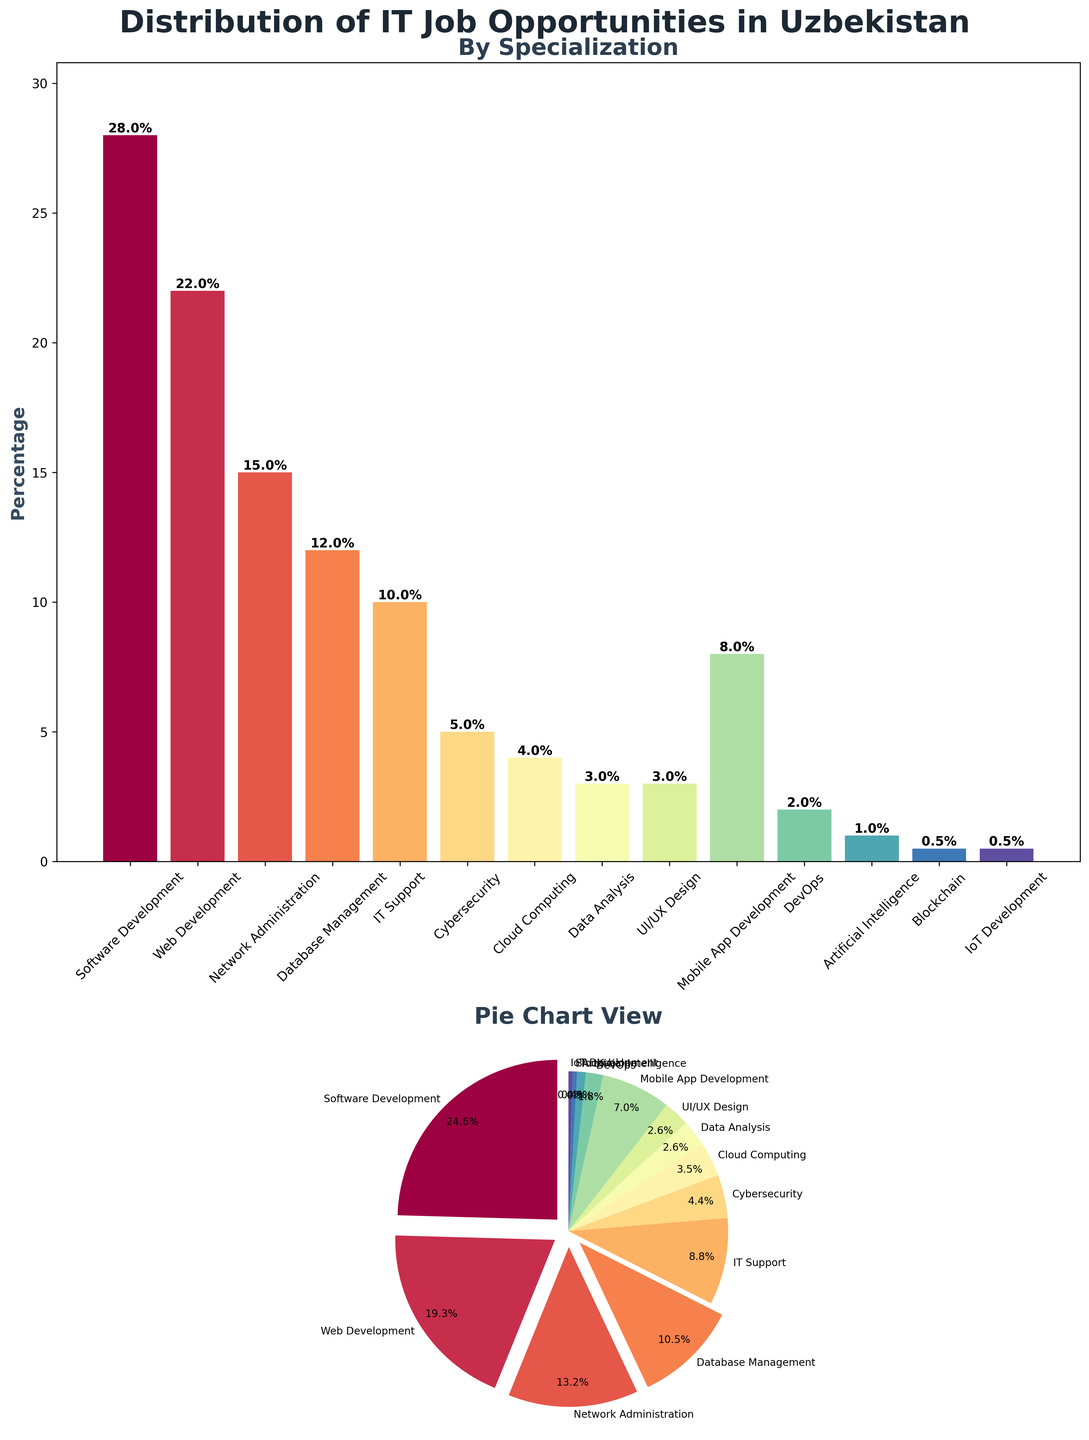Which specialization has the highest percentage of IT job opportunities in Uzbekistan? The bar plot shows the percentage of IT job opportunities by specialization, and the tallest bar represents Software Development at 28%.
Answer: Software Development Which two specializations have less than 3% of IT job opportunities each? Referring to the bar plot, the bars representing DevOps and Artificial Intelligence are below the 3% mark, with DevOps at 2% and Artificial Intelligence at 1%.
Answer: DevOps, Artificial Intelligence What is the total percentage of IT job opportunities for Cloud Computing, Data Analysis, and UI/UX Design combined? Adding the percentages from the bar plot: Cloud Computing (4%) + Data Analysis (3%) + UI/UX Design (3%) = 10%.
Answer: 10% Compare the job opportunities in Cybersecurity and Network Administration. Which one has more and by how much? From the bar plot, Cybersecurity has 5% and Network Administration has 15%. The difference is 15% - 5% = 10%.
Answer: Network Administration, by 10% Is the percentage of IT Support job opportunities greater than Mobile App Development? IT Support is shown at 10% on the bar plot, while Mobile App Development is at 8%. Therefore, IT Support has a higher percentage than Mobile App Development.
Answer: Yes How many specializations have a job opportunity percentage of 10% or higher? Referring to the bar plot, the specializations with percentages 10% or higher are Software Development (28%), Web Development (22%), Network Administration (15%), and IT Support (10%). This totals to 4 specializations.
Answer: 4 What visual indication shows the specializations that have more than 10% job opportunities in the pie chart? The pie chart has a visual feature where slices for specializations with more than 10% job opportunities are exploded out slightly, indicating their significance.
Answer: Exploded slices Which specialization has the smallest percentage of IT job opportunities and what is the value? The smallest bar in the bar plot represents Blockchain and IoT Development, each with a percentage of 0.5%.
Answer: Blockchain, IoT Development, 0.5% Between UI/UX Design and Mobile App Development, which specialization has fewer job opportunities, and what is the difference? UI/UX Design has 3% and Mobile App Development has 8% according to the bar plot. The difference is 8% - 3% = 5%.
Answer: UI/UX Design, by 5% 